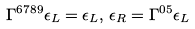Convert formula to latex. <formula><loc_0><loc_0><loc_500><loc_500>\Gamma ^ { 6 7 8 9 } \epsilon _ { L } = \epsilon _ { L } , \, \epsilon _ { R } = \Gamma ^ { 0 5 } \epsilon _ { L }</formula> 